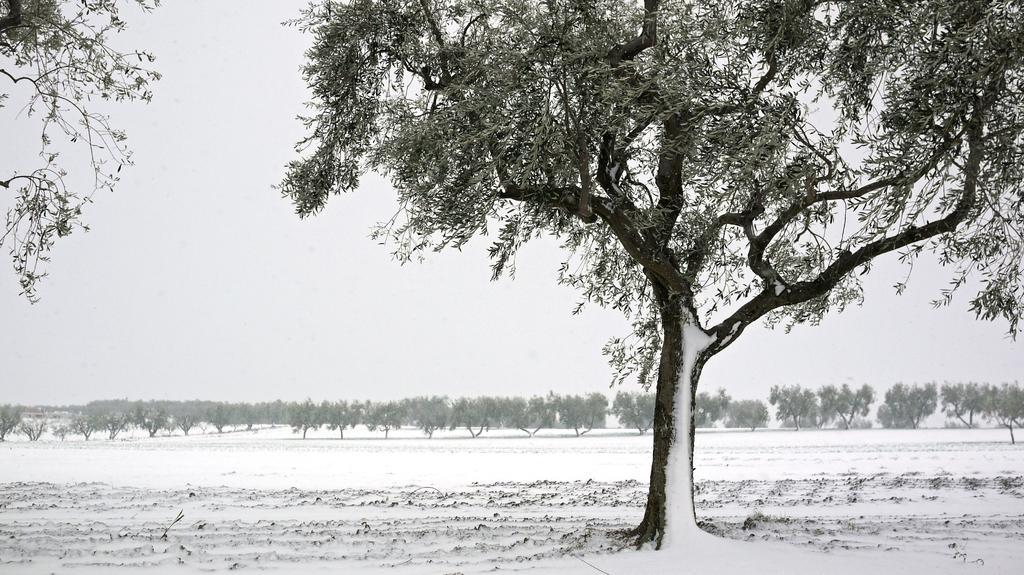Could you give a brief overview of what you see in this image? In this picture we can see trees and we can see sky in the background. 